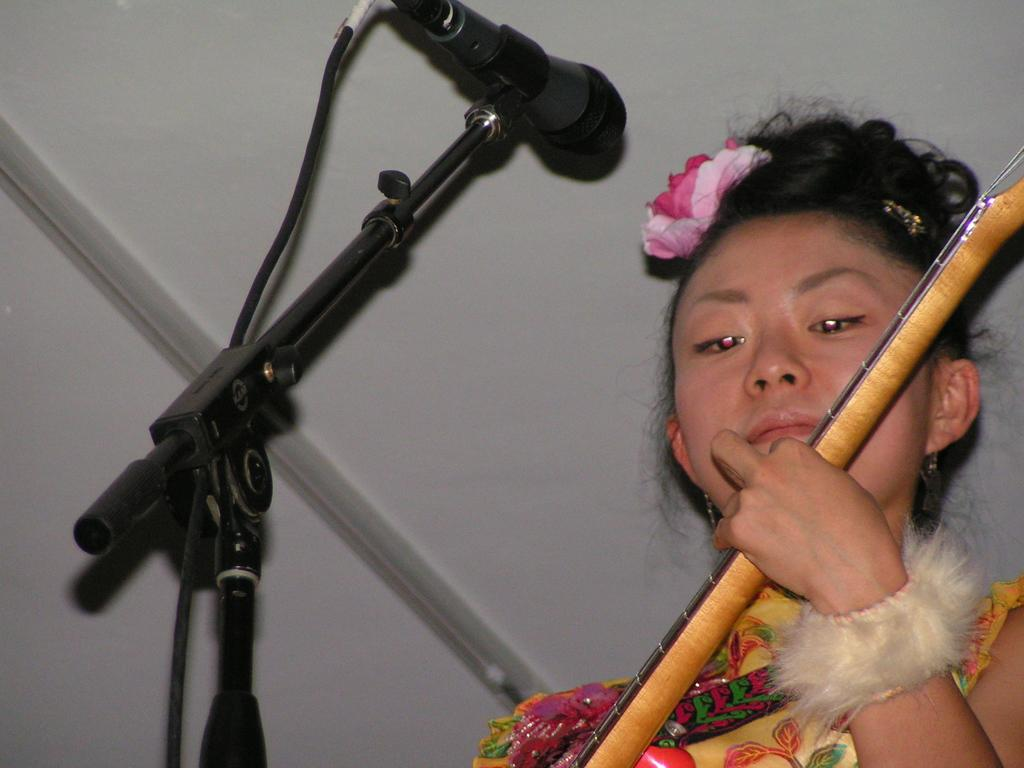Who is the main subject in the image? There is a woman in the image. What is the woman holding in the image? The woman is holding an object. What can be seen in front of the woman? There is a microphone in front of the woman. What type of property does the fireman own in the image? There is no fireman or property present in the image. 